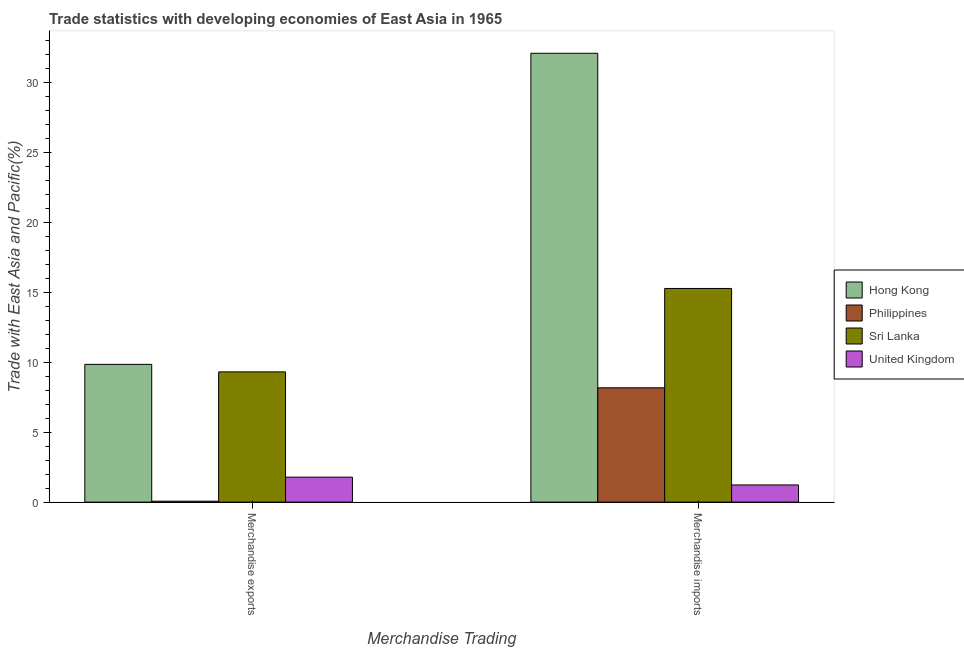How many different coloured bars are there?
Provide a short and direct response. 4. How many groups of bars are there?
Make the answer very short. 2. Are the number of bars on each tick of the X-axis equal?
Make the answer very short. Yes. How many bars are there on the 1st tick from the right?
Provide a succinct answer. 4. What is the merchandise exports in Hong Kong?
Provide a succinct answer. 9.85. Across all countries, what is the maximum merchandise imports?
Your answer should be very brief. 32.09. Across all countries, what is the minimum merchandise exports?
Give a very brief answer. 0.07. In which country was the merchandise exports maximum?
Give a very brief answer. Hong Kong. What is the total merchandise imports in the graph?
Your answer should be compact. 56.76. What is the difference between the merchandise exports in Hong Kong and that in United Kingdom?
Make the answer very short. 8.06. What is the difference between the merchandise exports in United Kingdom and the merchandise imports in Philippines?
Give a very brief answer. -6.39. What is the average merchandise exports per country?
Make the answer very short. 5.25. What is the difference between the merchandise imports and merchandise exports in Sri Lanka?
Offer a terse response. 5.96. In how many countries, is the merchandise exports greater than 19 %?
Provide a short and direct response. 0. What is the ratio of the merchandise exports in Philippines to that in Hong Kong?
Give a very brief answer. 0.01. Is the merchandise exports in United Kingdom less than that in Sri Lanka?
Your answer should be very brief. Yes. What does the 1st bar from the left in Merchandise imports represents?
Offer a very short reply. Hong Kong. Are all the bars in the graph horizontal?
Make the answer very short. No. How many countries are there in the graph?
Your answer should be very brief. 4. Does the graph contain any zero values?
Make the answer very short. No. Where does the legend appear in the graph?
Make the answer very short. Center right. How are the legend labels stacked?
Provide a succinct answer. Vertical. What is the title of the graph?
Give a very brief answer. Trade statistics with developing economies of East Asia in 1965. What is the label or title of the X-axis?
Your answer should be compact. Merchandise Trading. What is the label or title of the Y-axis?
Provide a succinct answer. Trade with East Asia and Pacific(%). What is the Trade with East Asia and Pacific(%) of Hong Kong in Merchandise exports?
Offer a very short reply. 9.85. What is the Trade with East Asia and Pacific(%) in Philippines in Merchandise exports?
Ensure brevity in your answer.  0.07. What is the Trade with East Asia and Pacific(%) of Sri Lanka in Merchandise exports?
Your response must be concise. 9.31. What is the Trade with East Asia and Pacific(%) of United Kingdom in Merchandise exports?
Provide a succinct answer. 1.79. What is the Trade with East Asia and Pacific(%) in Hong Kong in Merchandise imports?
Ensure brevity in your answer.  32.09. What is the Trade with East Asia and Pacific(%) of Philippines in Merchandise imports?
Make the answer very short. 8.17. What is the Trade with East Asia and Pacific(%) in Sri Lanka in Merchandise imports?
Provide a short and direct response. 15.27. What is the Trade with East Asia and Pacific(%) in United Kingdom in Merchandise imports?
Keep it short and to the point. 1.23. Across all Merchandise Trading, what is the maximum Trade with East Asia and Pacific(%) in Hong Kong?
Your answer should be compact. 32.09. Across all Merchandise Trading, what is the maximum Trade with East Asia and Pacific(%) of Philippines?
Your answer should be compact. 8.17. Across all Merchandise Trading, what is the maximum Trade with East Asia and Pacific(%) in Sri Lanka?
Provide a succinct answer. 15.27. Across all Merchandise Trading, what is the maximum Trade with East Asia and Pacific(%) in United Kingdom?
Offer a terse response. 1.79. Across all Merchandise Trading, what is the minimum Trade with East Asia and Pacific(%) of Hong Kong?
Your answer should be compact. 9.85. Across all Merchandise Trading, what is the minimum Trade with East Asia and Pacific(%) in Philippines?
Your answer should be very brief. 0.07. Across all Merchandise Trading, what is the minimum Trade with East Asia and Pacific(%) in Sri Lanka?
Offer a very short reply. 9.31. Across all Merchandise Trading, what is the minimum Trade with East Asia and Pacific(%) of United Kingdom?
Provide a short and direct response. 1.23. What is the total Trade with East Asia and Pacific(%) of Hong Kong in the graph?
Your answer should be very brief. 41.94. What is the total Trade with East Asia and Pacific(%) of Philippines in the graph?
Make the answer very short. 8.24. What is the total Trade with East Asia and Pacific(%) in Sri Lanka in the graph?
Your answer should be compact. 24.59. What is the total Trade with East Asia and Pacific(%) of United Kingdom in the graph?
Your answer should be very brief. 3.01. What is the difference between the Trade with East Asia and Pacific(%) in Hong Kong in Merchandise exports and that in Merchandise imports?
Make the answer very short. -22.24. What is the difference between the Trade with East Asia and Pacific(%) in Philippines in Merchandise exports and that in Merchandise imports?
Your response must be concise. -8.11. What is the difference between the Trade with East Asia and Pacific(%) of Sri Lanka in Merchandise exports and that in Merchandise imports?
Offer a terse response. -5.96. What is the difference between the Trade with East Asia and Pacific(%) in United Kingdom in Merchandise exports and that in Merchandise imports?
Keep it short and to the point. 0.56. What is the difference between the Trade with East Asia and Pacific(%) in Hong Kong in Merchandise exports and the Trade with East Asia and Pacific(%) in Philippines in Merchandise imports?
Offer a terse response. 1.68. What is the difference between the Trade with East Asia and Pacific(%) in Hong Kong in Merchandise exports and the Trade with East Asia and Pacific(%) in Sri Lanka in Merchandise imports?
Make the answer very short. -5.43. What is the difference between the Trade with East Asia and Pacific(%) in Hong Kong in Merchandise exports and the Trade with East Asia and Pacific(%) in United Kingdom in Merchandise imports?
Offer a terse response. 8.62. What is the difference between the Trade with East Asia and Pacific(%) of Philippines in Merchandise exports and the Trade with East Asia and Pacific(%) of Sri Lanka in Merchandise imports?
Make the answer very short. -15.21. What is the difference between the Trade with East Asia and Pacific(%) of Philippines in Merchandise exports and the Trade with East Asia and Pacific(%) of United Kingdom in Merchandise imports?
Your answer should be compact. -1.16. What is the difference between the Trade with East Asia and Pacific(%) of Sri Lanka in Merchandise exports and the Trade with East Asia and Pacific(%) of United Kingdom in Merchandise imports?
Provide a short and direct response. 8.08. What is the average Trade with East Asia and Pacific(%) of Hong Kong per Merchandise Trading?
Your answer should be very brief. 20.97. What is the average Trade with East Asia and Pacific(%) in Philippines per Merchandise Trading?
Your answer should be very brief. 4.12. What is the average Trade with East Asia and Pacific(%) of Sri Lanka per Merchandise Trading?
Make the answer very short. 12.29. What is the average Trade with East Asia and Pacific(%) in United Kingdom per Merchandise Trading?
Ensure brevity in your answer.  1.51. What is the difference between the Trade with East Asia and Pacific(%) in Hong Kong and Trade with East Asia and Pacific(%) in Philippines in Merchandise exports?
Ensure brevity in your answer.  9.78. What is the difference between the Trade with East Asia and Pacific(%) in Hong Kong and Trade with East Asia and Pacific(%) in Sri Lanka in Merchandise exports?
Make the answer very short. 0.54. What is the difference between the Trade with East Asia and Pacific(%) of Hong Kong and Trade with East Asia and Pacific(%) of United Kingdom in Merchandise exports?
Keep it short and to the point. 8.06. What is the difference between the Trade with East Asia and Pacific(%) in Philippines and Trade with East Asia and Pacific(%) in Sri Lanka in Merchandise exports?
Your response must be concise. -9.25. What is the difference between the Trade with East Asia and Pacific(%) of Philippines and Trade with East Asia and Pacific(%) of United Kingdom in Merchandise exports?
Offer a very short reply. -1.72. What is the difference between the Trade with East Asia and Pacific(%) in Sri Lanka and Trade with East Asia and Pacific(%) in United Kingdom in Merchandise exports?
Your answer should be very brief. 7.52. What is the difference between the Trade with East Asia and Pacific(%) of Hong Kong and Trade with East Asia and Pacific(%) of Philippines in Merchandise imports?
Ensure brevity in your answer.  23.92. What is the difference between the Trade with East Asia and Pacific(%) of Hong Kong and Trade with East Asia and Pacific(%) of Sri Lanka in Merchandise imports?
Your answer should be compact. 16.81. What is the difference between the Trade with East Asia and Pacific(%) of Hong Kong and Trade with East Asia and Pacific(%) of United Kingdom in Merchandise imports?
Make the answer very short. 30.86. What is the difference between the Trade with East Asia and Pacific(%) in Philippines and Trade with East Asia and Pacific(%) in Sri Lanka in Merchandise imports?
Offer a terse response. -7.1. What is the difference between the Trade with East Asia and Pacific(%) of Philippines and Trade with East Asia and Pacific(%) of United Kingdom in Merchandise imports?
Offer a very short reply. 6.94. What is the difference between the Trade with East Asia and Pacific(%) in Sri Lanka and Trade with East Asia and Pacific(%) in United Kingdom in Merchandise imports?
Make the answer very short. 14.05. What is the ratio of the Trade with East Asia and Pacific(%) of Hong Kong in Merchandise exports to that in Merchandise imports?
Offer a very short reply. 0.31. What is the ratio of the Trade with East Asia and Pacific(%) of Philippines in Merchandise exports to that in Merchandise imports?
Offer a very short reply. 0.01. What is the ratio of the Trade with East Asia and Pacific(%) in Sri Lanka in Merchandise exports to that in Merchandise imports?
Provide a succinct answer. 0.61. What is the ratio of the Trade with East Asia and Pacific(%) of United Kingdom in Merchandise exports to that in Merchandise imports?
Your answer should be compact. 1.46. What is the difference between the highest and the second highest Trade with East Asia and Pacific(%) in Hong Kong?
Your answer should be very brief. 22.24. What is the difference between the highest and the second highest Trade with East Asia and Pacific(%) of Philippines?
Offer a very short reply. 8.11. What is the difference between the highest and the second highest Trade with East Asia and Pacific(%) in Sri Lanka?
Your response must be concise. 5.96. What is the difference between the highest and the second highest Trade with East Asia and Pacific(%) in United Kingdom?
Your answer should be compact. 0.56. What is the difference between the highest and the lowest Trade with East Asia and Pacific(%) in Hong Kong?
Give a very brief answer. 22.24. What is the difference between the highest and the lowest Trade with East Asia and Pacific(%) of Philippines?
Give a very brief answer. 8.11. What is the difference between the highest and the lowest Trade with East Asia and Pacific(%) of Sri Lanka?
Your answer should be compact. 5.96. What is the difference between the highest and the lowest Trade with East Asia and Pacific(%) of United Kingdom?
Give a very brief answer. 0.56. 